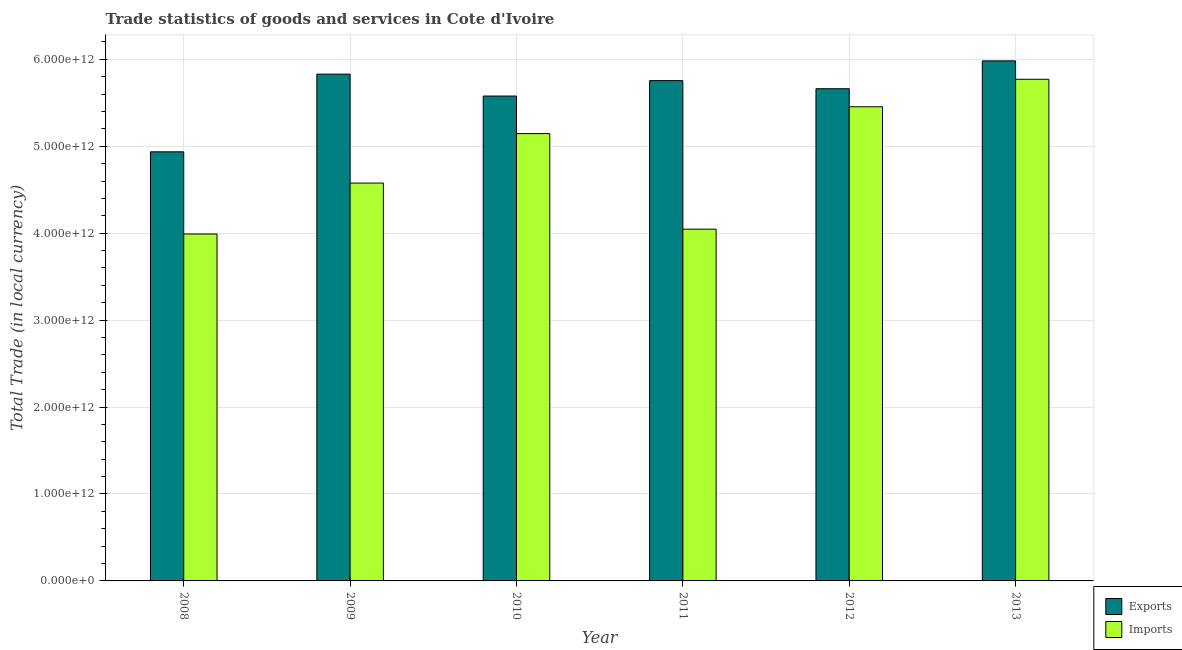Are the number of bars on each tick of the X-axis equal?
Provide a succinct answer. Yes. How many bars are there on the 3rd tick from the left?
Give a very brief answer. 2. In how many cases, is the number of bars for a given year not equal to the number of legend labels?
Ensure brevity in your answer.  0. What is the export of goods and services in 2010?
Provide a succinct answer. 5.58e+12. Across all years, what is the maximum export of goods and services?
Make the answer very short. 5.98e+12. Across all years, what is the minimum export of goods and services?
Provide a succinct answer. 4.94e+12. What is the total imports of goods and services in the graph?
Ensure brevity in your answer.  2.90e+13. What is the difference between the export of goods and services in 2011 and that in 2012?
Your answer should be very brief. 9.32e+1. What is the difference between the imports of goods and services in 2011 and the export of goods and services in 2012?
Make the answer very short. -1.41e+12. What is the average export of goods and services per year?
Provide a short and direct response. 5.62e+12. In how many years, is the imports of goods and services greater than 4800000000000 LCU?
Provide a succinct answer. 3. What is the ratio of the imports of goods and services in 2010 to that in 2012?
Keep it short and to the point. 0.94. Is the export of goods and services in 2008 less than that in 2013?
Offer a terse response. Yes. What is the difference between the highest and the second highest export of goods and services?
Your response must be concise. 1.53e+11. What is the difference between the highest and the lowest imports of goods and services?
Ensure brevity in your answer.  1.78e+12. Is the sum of the imports of goods and services in 2011 and 2012 greater than the maximum export of goods and services across all years?
Provide a short and direct response. Yes. What does the 2nd bar from the left in 2013 represents?
Provide a short and direct response. Imports. What does the 1st bar from the right in 2013 represents?
Your answer should be very brief. Imports. Are all the bars in the graph horizontal?
Offer a very short reply. No. What is the difference between two consecutive major ticks on the Y-axis?
Offer a very short reply. 1.00e+12. Are the values on the major ticks of Y-axis written in scientific E-notation?
Give a very brief answer. Yes. Does the graph contain any zero values?
Give a very brief answer. No. Where does the legend appear in the graph?
Make the answer very short. Bottom right. How many legend labels are there?
Provide a short and direct response. 2. How are the legend labels stacked?
Your answer should be very brief. Vertical. What is the title of the graph?
Your answer should be compact. Trade statistics of goods and services in Cote d'Ivoire. Does "Arms exports" appear as one of the legend labels in the graph?
Your answer should be compact. No. What is the label or title of the Y-axis?
Your answer should be very brief. Total Trade (in local currency). What is the Total Trade (in local currency) of Exports in 2008?
Your answer should be compact. 4.94e+12. What is the Total Trade (in local currency) of Imports in 2008?
Provide a succinct answer. 3.99e+12. What is the Total Trade (in local currency) of Exports in 2009?
Keep it short and to the point. 5.83e+12. What is the Total Trade (in local currency) in Imports in 2009?
Make the answer very short. 4.58e+12. What is the Total Trade (in local currency) of Exports in 2010?
Ensure brevity in your answer.  5.58e+12. What is the Total Trade (in local currency) in Imports in 2010?
Provide a succinct answer. 5.15e+12. What is the Total Trade (in local currency) in Exports in 2011?
Your answer should be very brief. 5.76e+12. What is the Total Trade (in local currency) of Imports in 2011?
Give a very brief answer. 4.05e+12. What is the Total Trade (in local currency) of Exports in 2012?
Keep it short and to the point. 5.66e+12. What is the Total Trade (in local currency) in Imports in 2012?
Your response must be concise. 5.45e+12. What is the Total Trade (in local currency) of Exports in 2013?
Your answer should be compact. 5.98e+12. What is the Total Trade (in local currency) in Imports in 2013?
Provide a succinct answer. 5.77e+12. Across all years, what is the maximum Total Trade (in local currency) in Exports?
Provide a short and direct response. 5.98e+12. Across all years, what is the maximum Total Trade (in local currency) in Imports?
Your answer should be very brief. 5.77e+12. Across all years, what is the minimum Total Trade (in local currency) of Exports?
Your answer should be very brief. 4.94e+12. Across all years, what is the minimum Total Trade (in local currency) in Imports?
Your answer should be compact. 3.99e+12. What is the total Total Trade (in local currency) in Exports in the graph?
Your answer should be compact. 3.37e+13. What is the total Total Trade (in local currency) of Imports in the graph?
Offer a very short reply. 2.90e+13. What is the difference between the Total Trade (in local currency) of Exports in 2008 and that in 2009?
Keep it short and to the point. -8.94e+11. What is the difference between the Total Trade (in local currency) in Imports in 2008 and that in 2009?
Your response must be concise. -5.86e+11. What is the difference between the Total Trade (in local currency) in Exports in 2008 and that in 2010?
Offer a terse response. -6.42e+11. What is the difference between the Total Trade (in local currency) in Imports in 2008 and that in 2010?
Make the answer very short. -1.15e+12. What is the difference between the Total Trade (in local currency) in Exports in 2008 and that in 2011?
Ensure brevity in your answer.  -8.19e+11. What is the difference between the Total Trade (in local currency) in Imports in 2008 and that in 2011?
Make the answer very short. -5.56e+1. What is the difference between the Total Trade (in local currency) in Exports in 2008 and that in 2012?
Keep it short and to the point. -7.26e+11. What is the difference between the Total Trade (in local currency) of Imports in 2008 and that in 2012?
Provide a succinct answer. -1.46e+12. What is the difference between the Total Trade (in local currency) of Exports in 2008 and that in 2013?
Keep it short and to the point. -1.05e+12. What is the difference between the Total Trade (in local currency) of Imports in 2008 and that in 2013?
Ensure brevity in your answer.  -1.78e+12. What is the difference between the Total Trade (in local currency) in Exports in 2009 and that in 2010?
Make the answer very short. 2.52e+11. What is the difference between the Total Trade (in local currency) of Imports in 2009 and that in 2010?
Make the answer very short. -5.69e+11. What is the difference between the Total Trade (in local currency) in Exports in 2009 and that in 2011?
Offer a very short reply. 7.47e+1. What is the difference between the Total Trade (in local currency) of Imports in 2009 and that in 2011?
Keep it short and to the point. 5.30e+11. What is the difference between the Total Trade (in local currency) in Exports in 2009 and that in 2012?
Your response must be concise. 1.68e+11. What is the difference between the Total Trade (in local currency) in Imports in 2009 and that in 2012?
Offer a terse response. -8.78e+11. What is the difference between the Total Trade (in local currency) in Exports in 2009 and that in 2013?
Make the answer very short. -1.53e+11. What is the difference between the Total Trade (in local currency) in Imports in 2009 and that in 2013?
Offer a very short reply. -1.19e+12. What is the difference between the Total Trade (in local currency) in Exports in 2010 and that in 2011?
Offer a very short reply. -1.77e+11. What is the difference between the Total Trade (in local currency) in Imports in 2010 and that in 2011?
Your answer should be very brief. 1.10e+12. What is the difference between the Total Trade (in local currency) in Exports in 2010 and that in 2012?
Your answer should be compact. -8.40e+1. What is the difference between the Total Trade (in local currency) in Imports in 2010 and that in 2012?
Provide a short and direct response. -3.09e+11. What is the difference between the Total Trade (in local currency) of Exports in 2010 and that in 2013?
Offer a terse response. -4.04e+11. What is the difference between the Total Trade (in local currency) of Imports in 2010 and that in 2013?
Your answer should be compact. -6.25e+11. What is the difference between the Total Trade (in local currency) in Exports in 2011 and that in 2012?
Ensure brevity in your answer.  9.32e+1. What is the difference between the Total Trade (in local currency) of Imports in 2011 and that in 2012?
Ensure brevity in your answer.  -1.41e+12. What is the difference between the Total Trade (in local currency) of Exports in 2011 and that in 2013?
Make the answer very short. -2.27e+11. What is the difference between the Total Trade (in local currency) of Imports in 2011 and that in 2013?
Give a very brief answer. -1.72e+12. What is the difference between the Total Trade (in local currency) of Exports in 2012 and that in 2013?
Your answer should be compact. -3.20e+11. What is the difference between the Total Trade (in local currency) of Imports in 2012 and that in 2013?
Your answer should be compact. -3.16e+11. What is the difference between the Total Trade (in local currency) in Exports in 2008 and the Total Trade (in local currency) in Imports in 2009?
Make the answer very short. 3.59e+11. What is the difference between the Total Trade (in local currency) in Exports in 2008 and the Total Trade (in local currency) in Imports in 2010?
Provide a short and direct response. -2.09e+11. What is the difference between the Total Trade (in local currency) in Exports in 2008 and the Total Trade (in local currency) in Imports in 2011?
Provide a succinct answer. 8.90e+11. What is the difference between the Total Trade (in local currency) of Exports in 2008 and the Total Trade (in local currency) of Imports in 2012?
Give a very brief answer. -5.18e+11. What is the difference between the Total Trade (in local currency) of Exports in 2008 and the Total Trade (in local currency) of Imports in 2013?
Provide a succinct answer. -8.34e+11. What is the difference between the Total Trade (in local currency) in Exports in 2009 and the Total Trade (in local currency) in Imports in 2010?
Make the answer very short. 6.84e+11. What is the difference between the Total Trade (in local currency) of Exports in 2009 and the Total Trade (in local currency) of Imports in 2011?
Your answer should be compact. 1.78e+12. What is the difference between the Total Trade (in local currency) of Exports in 2009 and the Total Trade (in local currency) of Imports in 2012?
Make the answer very short. 3.75e+11. What is the difference between the Total Trade (in local currency) in Exports in 2009 and the Total Trade (in local currency) in Imports in 2013?
Provide a short and direct response. 5.91e+1. What is the difference between the Total Trade (in local currency) in Exports in 2010 and the Total Trade (in local currency) in Imports in 2011?
Provide a short and direct response. 1.53e+12. What is the difference between the Total Trade (in local currency) of Exports in 2010 and the Total Trade (in local currency) of Imports in 2012?
Keep it short and to the point. 1.24e+11. What is the difference between the Total Trade (in local currency) of Exports in 2010 and the Total Trade (in local currency) of Imports in 2013?
Give a very brief answer. -1.93e+11. What is the difference between the Total Trade (in local currency) in Exports in 2011 and the Total Trade (in local currency) in Imports in 2012?
Ensure brevity in your answer.  3.01e+11. What is the difference between the Total Trade (in local currency) of Exports in 2011 and the Total Trade (in local currency) of Imports in 2013?
Provide a succinct answer. -1.56e+1. What is the difference between the Total Trade (in local currency) in Exports in 2012 and the Total Trade (in local currency) in Imports in 2013?
Provide a succinct answer. -1.09e+11. What is the average Total Trade (in local currency) of Exports per year?
Offer a very short reply. 5.62e+12. What is the average Total Trade (in local currency) in Imports per year?
Provide a short and direct response. 4.83e+12. In the year 2008, what is the difference between the Total Trade (in local currency) of Exports and Total Trade (in local currency) of Imports?
Ensure brevity in your answer.  9.45e+11. In the year 2009, what is the difference between the Total Trade (in local currency) in Exports and Total Trade (in local currency) in Imports?
Give a very brief answer. 1.25e+12. In the year 2010, what is the difference between the Total Trade (in local currency) of Exports and Total Trade (in local currency) of Imports?
Your answer should be very brief. 4.32e+11. In the year 2011, what is the difference between the Total Trade (in local currency) in Exports and Total Trade (in local currency) in Imports?
Offer a terse response. 1.71e+12. In the year 2012, what is the difference between the Total Trade (in local currency) of Exports and Total Trade (in local currency) of Imports?
Your answer should be very brief. 2.08e+11. In the year 2013, what is the difference between the Total Trade (in local currency) of Exports and Total Trade (in local currency) of Imports?
Offer a terse response. 2.12e+11. What is the ratio of the Total Trade (in local currency) in Exports in 2008 to that in 2009?
Your response must be concise. 0.85. What is the ratio of the Total Trade (in local currency) in Imports in 2008 to that in 2009?
Your answer should be very brief. 0.87. What is the ratio of the Total Trade (in local currency) of Exports in 2008 to that in 2010?
Ensure brevity in your answer.  0.89. What is the ratio of the Total Trade (in local currency) in Imports in 2008 to that in 2010?
Offer a very short reply. 0.78. What is the ratio of the Total Trade (in local currency) of Exports in 2008 to that in 2011?
Offer a terse response. 0.86. What is the ratio of the Total Trade (in local currency) of Imports in 2008 to that in 2011?
Provide a succinct answer. 0.99. What is the ratio of the Total Trade (in local currency) in Exports in 2008 to that in 2012?
Provide a short and direct response. 0.87. What is the ratio of the Total Trade (in local currency) of Imports in 2008 to that in 2012?
Your answer should be very brief. 0.73. What is the ratio of the Total Trade (in local currency) in Exports in 2008 to that in 2013?
Provide a short and direct response. 0.83. What is the ratio of the Total Trade (in local currency) of Imports in 2008 to that in 2013?
Ensure brevity in your answer.  0.69. What is the ratio of the Total Trade (in local currency) in Exports in 2009 to that in 2010?
Ensure brevity in your answer.  1.05. What is the ratio of the Total Trade (in local currency) in Imports in 2009 to that in 2010?
Offer a terse response. 0.89. What is the ratio of the Total Trade (in local currency) in Imports in 2009 to that in 2011?
Ensure brevity in your answer.  1.13. What is the ratio of the Total Trade (in local currency) in Exports in 2009 to that in 2012?
Provide a succinct answer. 1.03. What is the ratio of the Total Trade (in local currency) in Imports in 2009 to that in 2012?
Give a very brief answer. 0.84. What is the ratio of the Total Trade (in local currency) of Exports in 2009 to that in 2013?
Provide a short and direct response. 0.97. What is the ratio of the Total Trade (in local currency) of Imports in 2009 to that in 2013?
Provide a succinct answer. 0.79. What is the ratio of the Total Trade (in local currency) of Exports in 2010 to that in 2011?
Make the answer very short. 0.97. What is the ratio of the Total Trade (in local currency) of Imports in 2010 to that in 2011?
Your answer should be very brief. 1.27. What is the ratio of the Total Trade (in local currency) of Exports in 2010 to that in 2012?
Give a very brief answer. 0.99. What is the ratio of the Total Trade (in local currency) in Imports in 2010 to that in 2012?
Give a very brief answer. 0.94. What is the ratio of the Total Trade (in local currency) of Exports in 2010 to that in 2013?
Your answer should be compact. 0.93. What is the ratio of the Total Trade (in local currency) in Imports in 2010 to that in 2013?
Your answer should be very brief. 0.89. What is the ratio of the Total Trade (in local currency) of Exports in 2011 to that in 2012?
Your answer should be very brief. 1.02. What is the ratio of the Total Trade (in local currency) of Imports in 2011 to that in 2012?
Keep it short and to the point. 0.74. What is the ratio of the Total Trade (in local currency) in Exports in 2011 to that in 2013?
Provide a succinct answer. 0.96. What is the ratio of the Total Trade (in local currency) in Imports in 2011 to that in 2013?
Provide a succinct answer. 0.7. What is the ratio of the Total Trade (in local currency) in Exports in 2012 to that in 2013?
Keep it short and to the point. 0.95. What is the ratio of the Total Trade (in local currency) of Imports in 2012 to that in 2013?
Provide a succinct answer. 0.95. What is the difference between the highest and the second highest Total Trade (in local currency) of Exports?
Your response must be concise. 1.53e+11. What is the difference between the highest and the second highest Total Trade (in local currency) of Imports?
Provide a succinct answer. 3.16e+11. What is the difference between the highest and the lowest Total Trade (in local currency) in Exports?
Offer a very short reply. 1.05e+12. What is the difference between the highest and the lowest Total Trade (in local currency) of Imports?
Provide a succinct answer. 1.78e+12. 